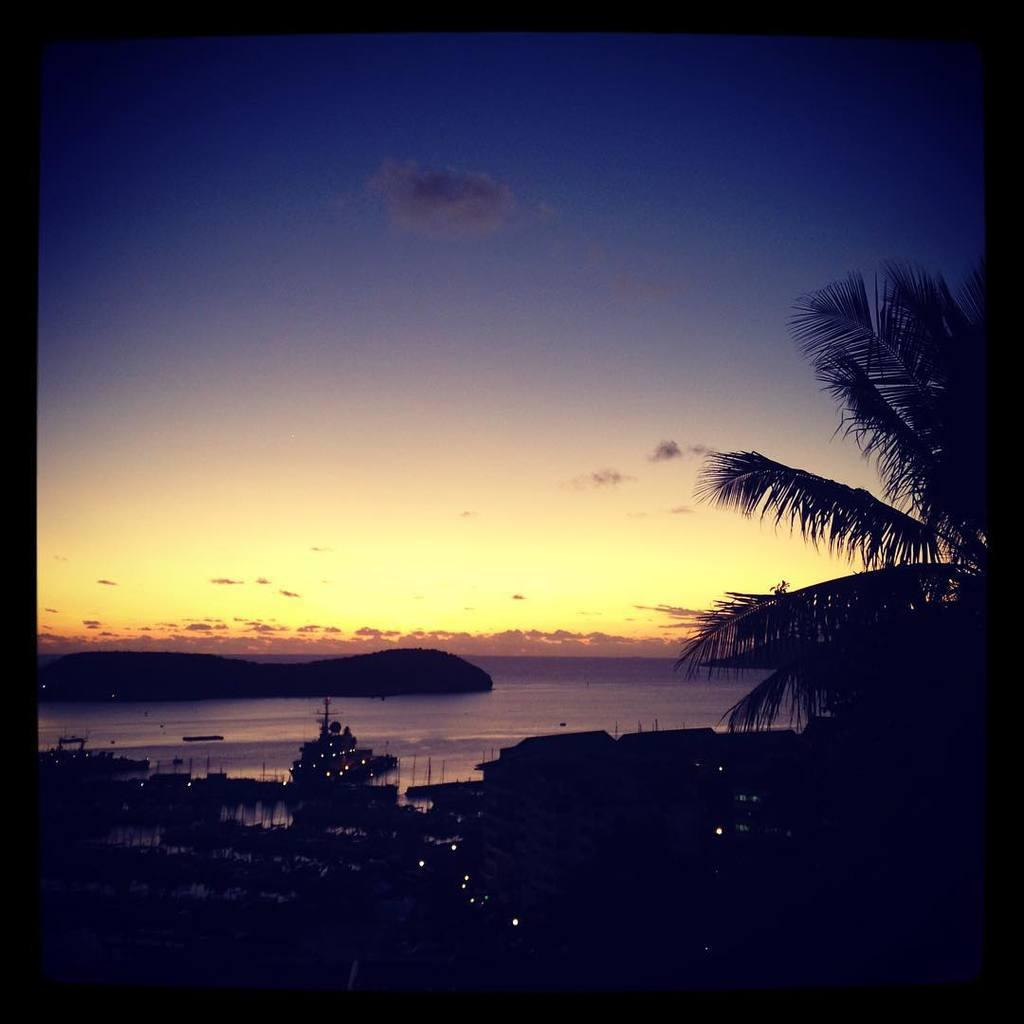What type of natural elements can be seen in the image? There are trees in the image. What type of man-made structures are present in the image? There are buildings in the image. What geographical feature is visible in the background of the image? There is a hill visible in the background of the image. What is the condition of the sky in the image? The sky is clear in the image. What type of screw is being used to hold the trees together in the image? There is no screw present in the image; the trees are natural elements and not held together by any screws. What is being served for lunch in the image? There is no reference to lunch or any food in the image. 